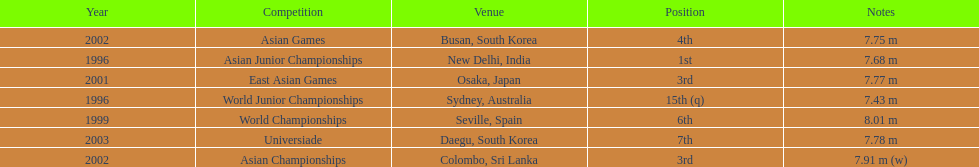How many times did his jump surpass 7.70 m? 5. 